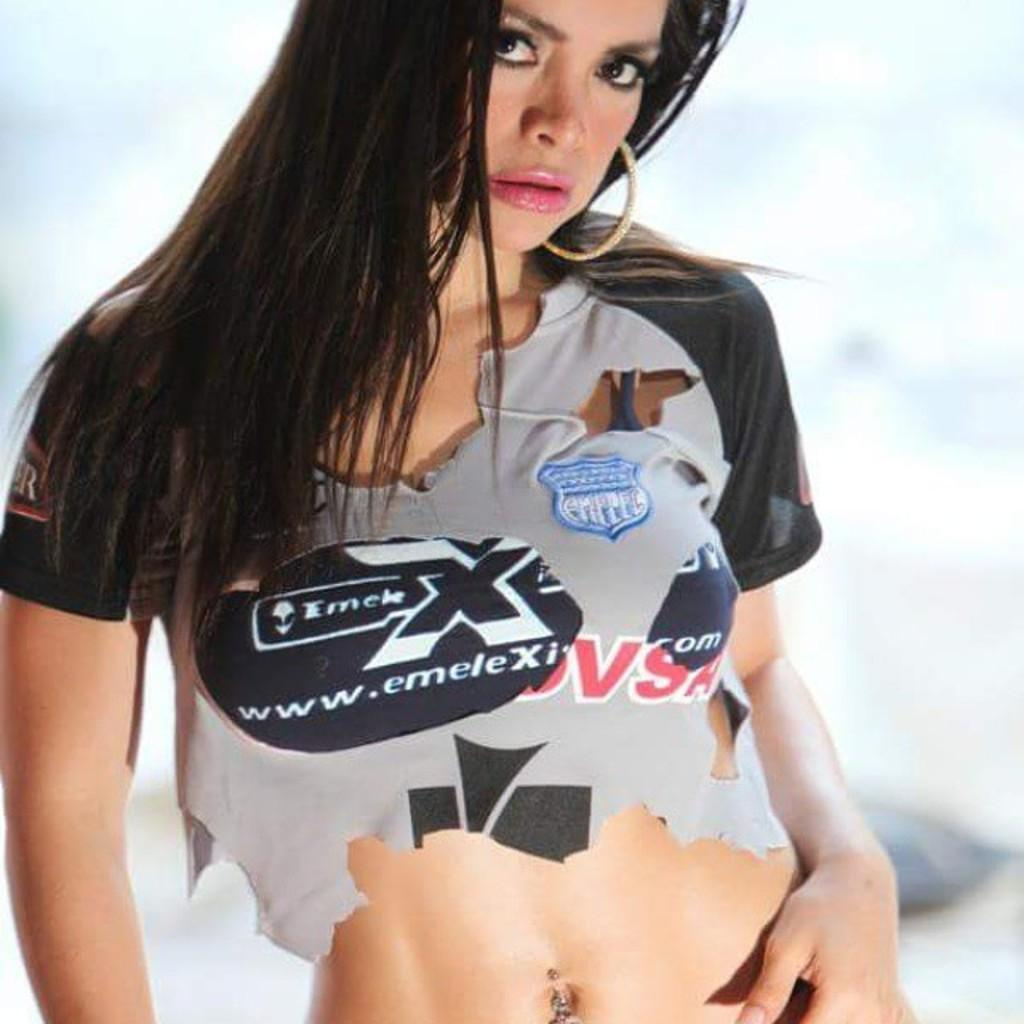<image>
Relay a brief, clear account of the picture shown. a lady with a site on her shirt that says www.emele.xi 